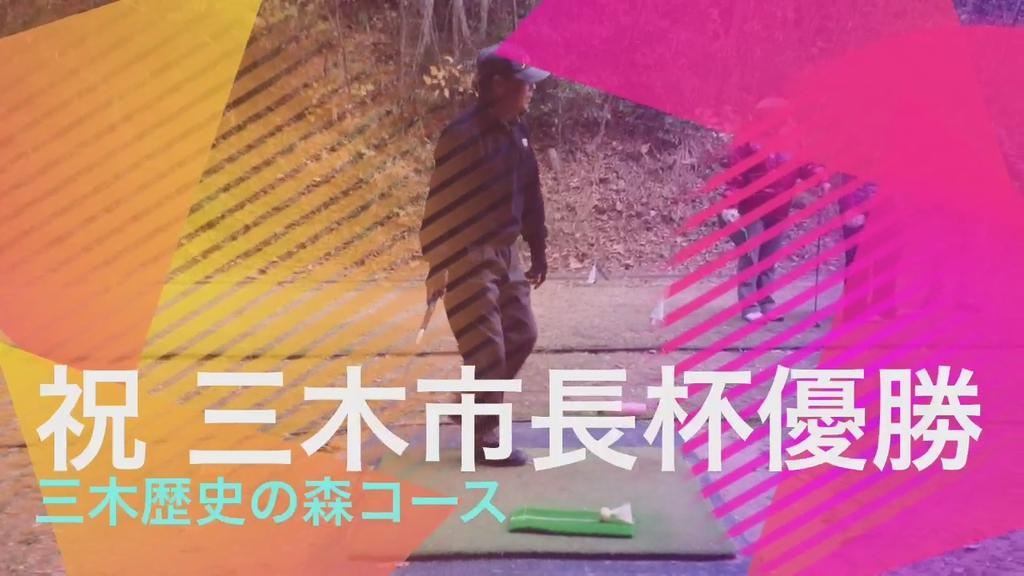What is the primary setting of the image? There are people standing on land in the image. What can be seen in the background of the image? There are trees in the background of the image. Is there any text present in the image? Yes, there is text present in the image. Can you describe the colors visible in the image? There are colors visible in the image. What type of rice is being grown in the alley in the image? There is no alley or rice present in the image. 